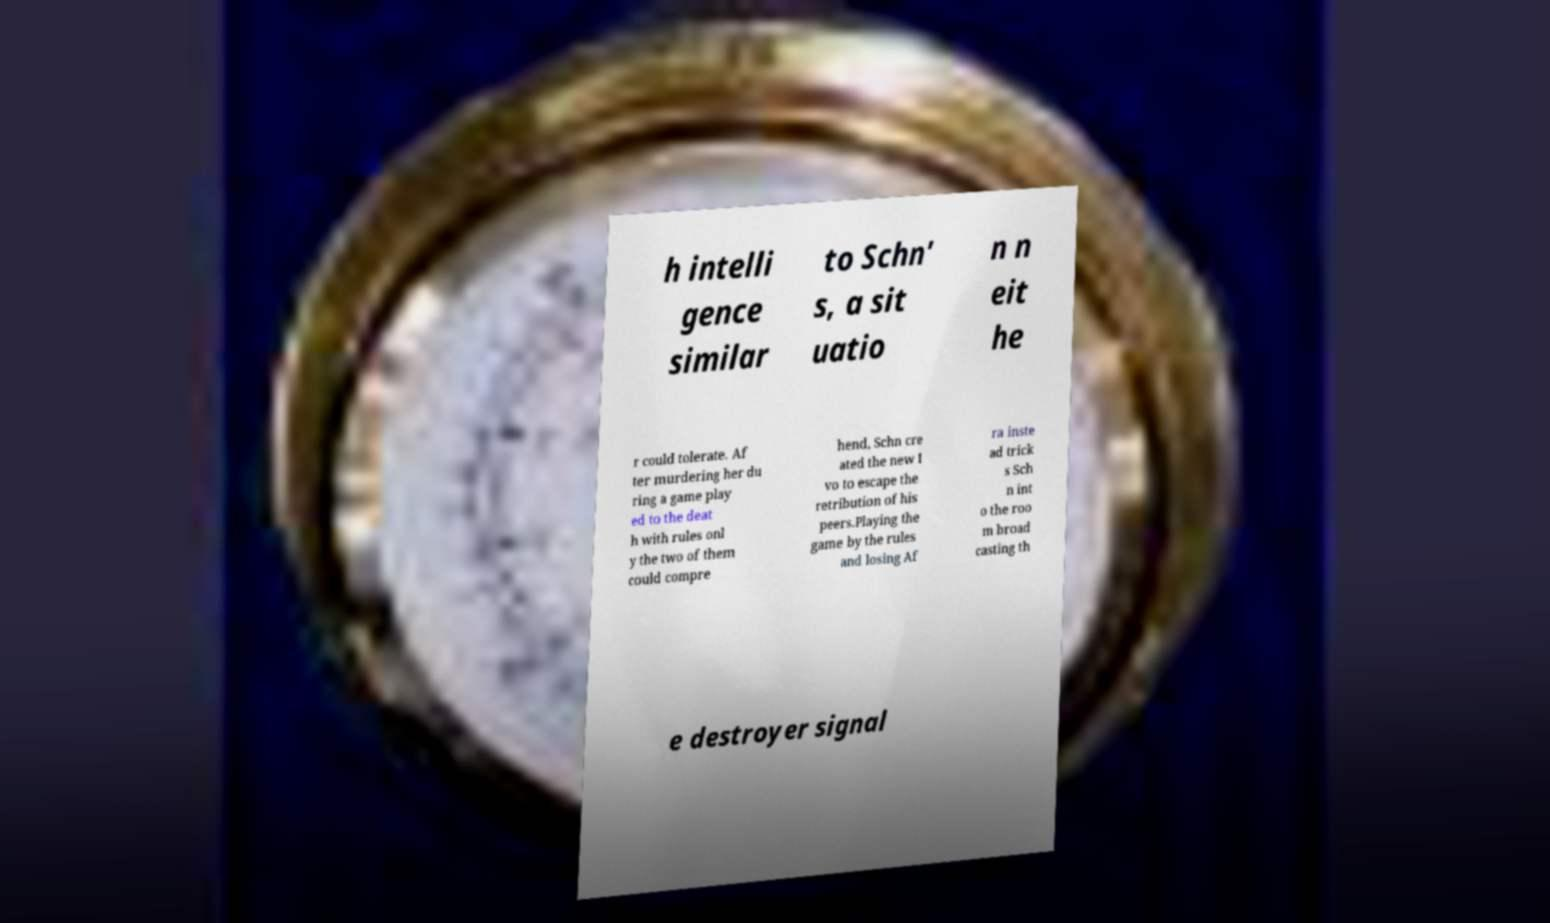What messages or text are displayed in this image? I need them in a readable, typed format. h intelli gence similar to Schn' s, a sit uatio n n eit he r could tolerate. Af ter murdering her du ring a game play ed to the deat h with rules onl y the two of them could compre hend, Schn cre ated the new I vo to escape the retribution of his peers.Playing the game by the rules and losing Af ra inste ad trick s Sch n int o the roo m broad casting th e destroyer signal 